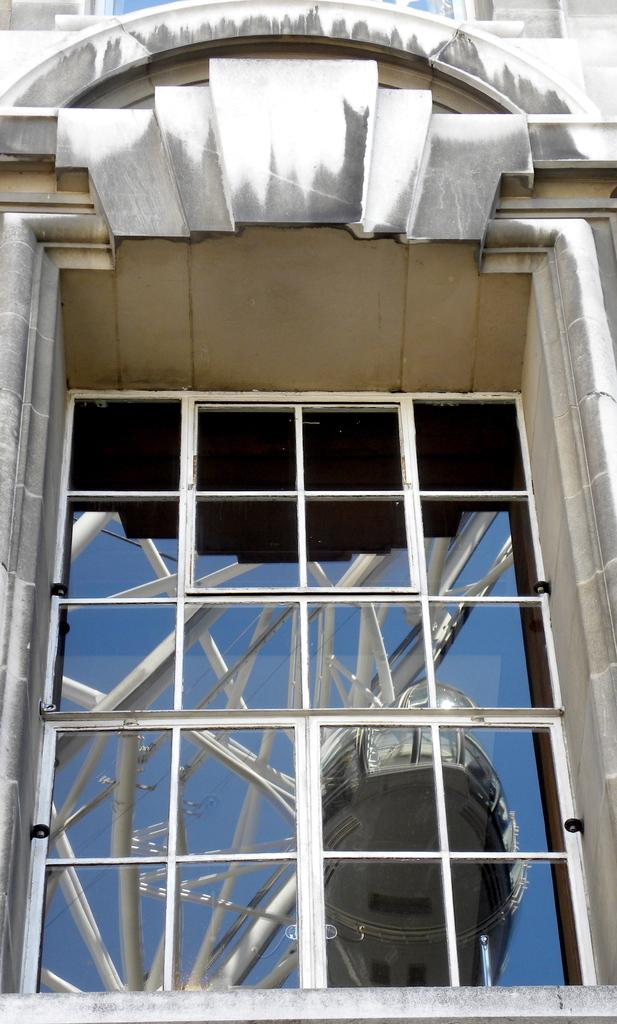What type of structure is visible in the image? There is a glass window in the image. How many rabbits are holding a chain while twisting around in the image? There are no rabbits or chains present in the image; it only features a glass window. 